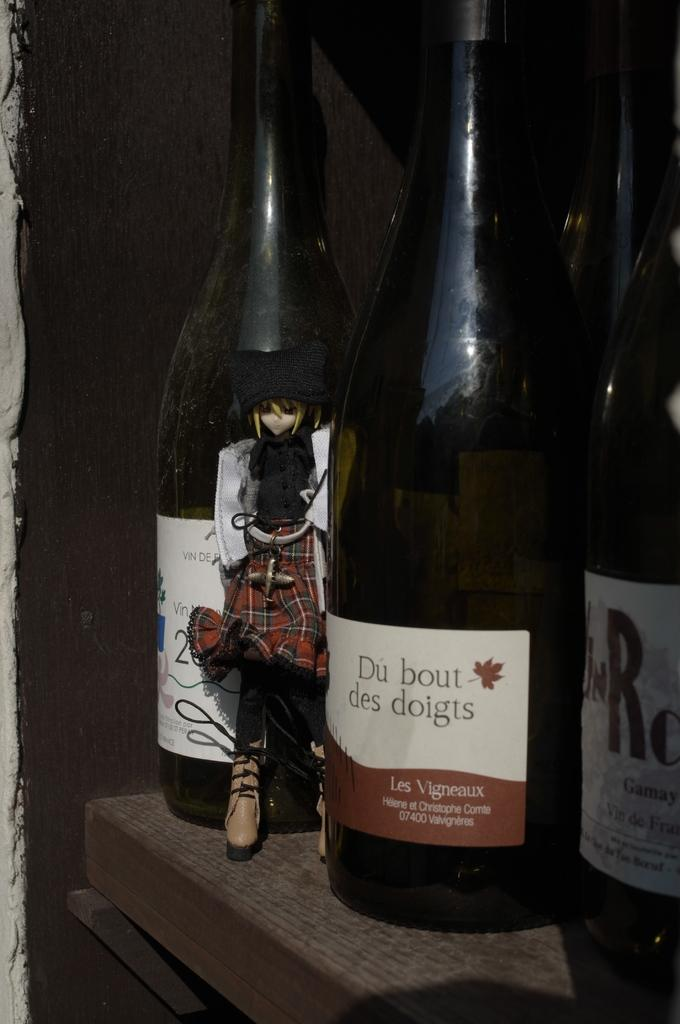<image>
Render a clear and concise summary of the photo. 3 bottles of wine with du bout des doigts in the middle 